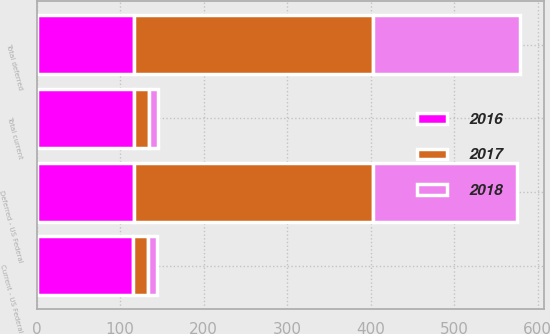Convert chart. <chart><loc_0><loc_0><loc_500><loc_500><stacked_bar_chart><ecel><fcel>Current - US Federal<fcel>Total current<fcel>Deferred - US Federal<fcel>Total deferred<nl><fcel>2017<fcel>18<fcel>18<fcel>286<fcel>286<nl><fcel>2016<fcel>116<fcel>117<fcel>116.5<fcel>116.5<nl><fcel>2018<fcel>10<fcel>10<fcel>173<fcel>176<nl></chart> 